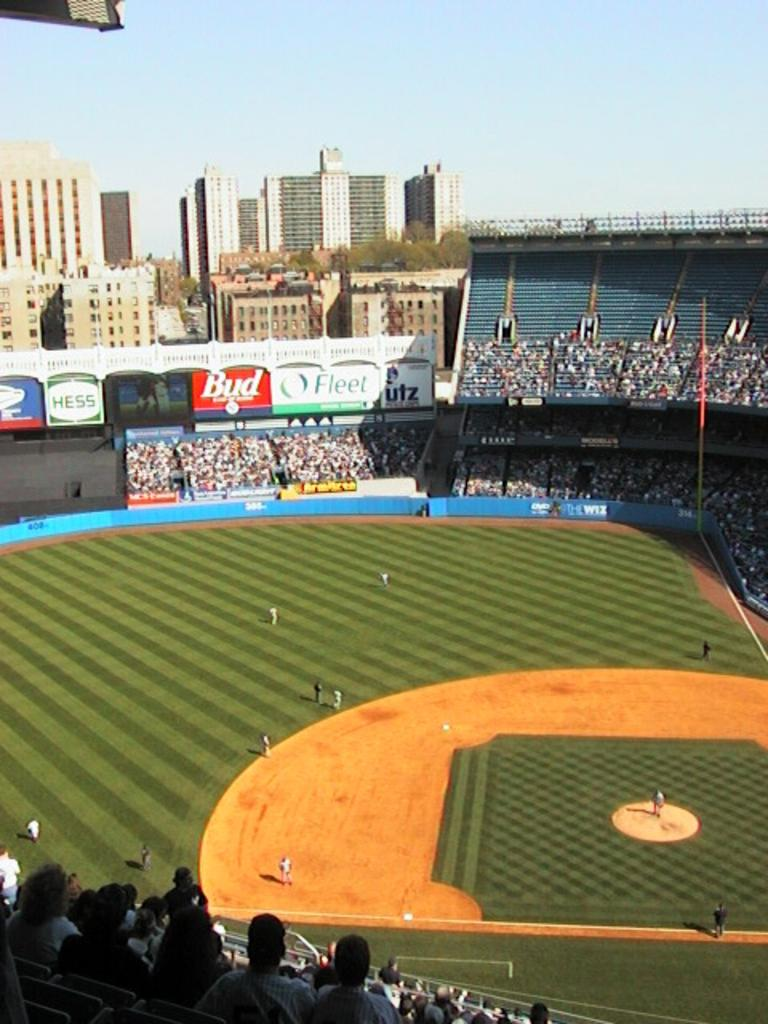<image>
Relay a brief, clear account of the picture shown. Several large billboards, including one for Hess, adorn the outfield of a baseball stadium. 